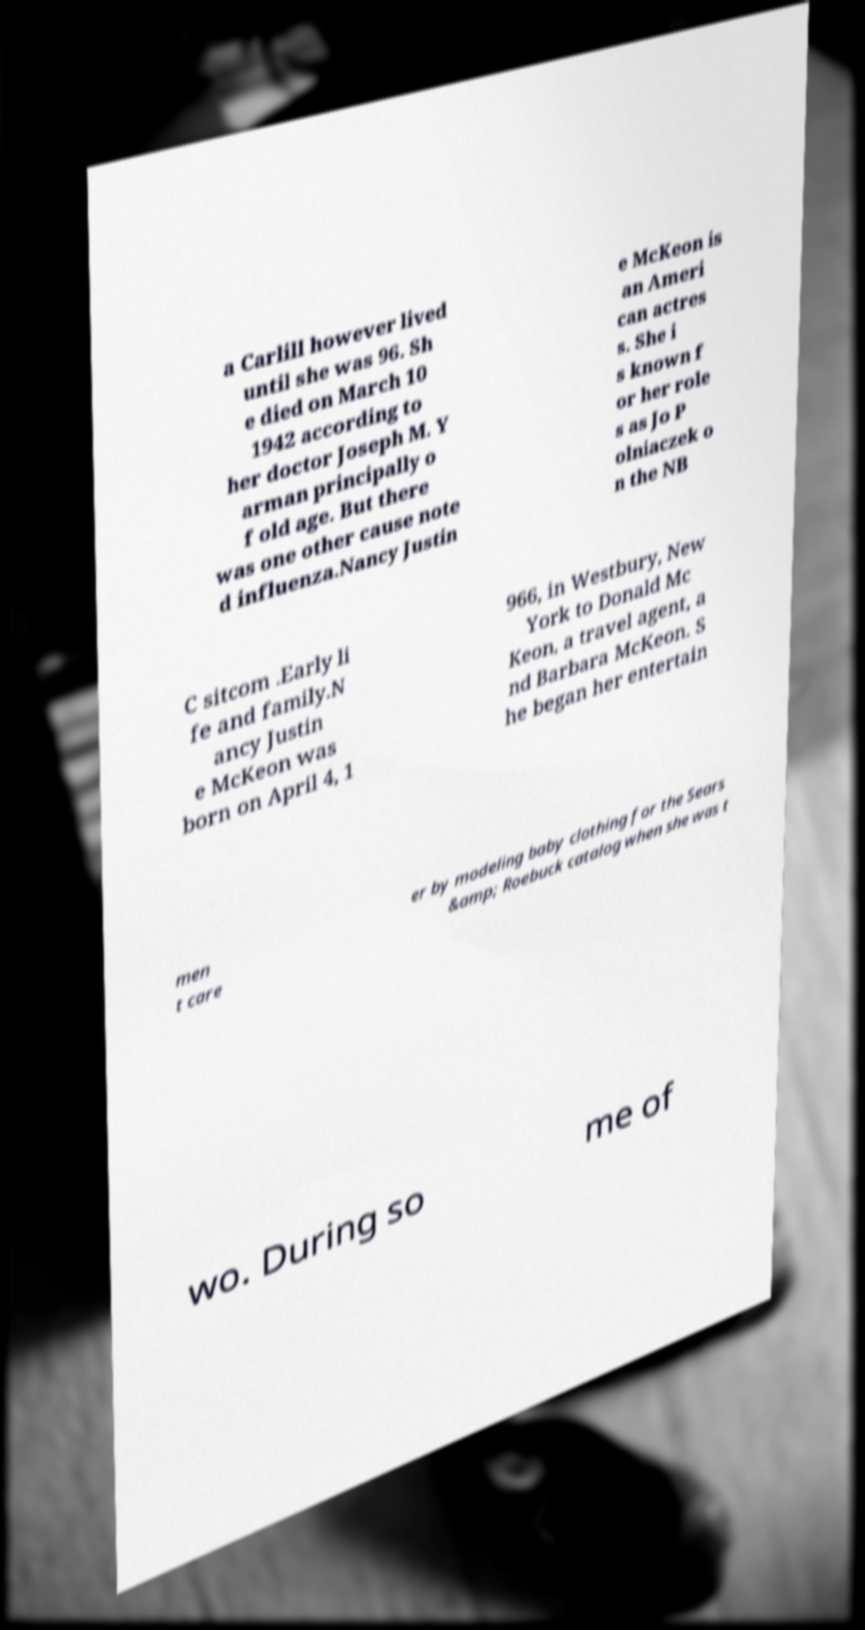Could you extract and type out the text from this image? a Carlill however lived until she was 96. Sh e died on March 10 1942 according to her doctor Joseph M. Y arman principally o f old age. But there was one other cause note d influenza.Nancy Justin e McKeon is an Ameri can actres s. She i s known f or her role s as Jo P olniaczek o n the NB C sitcom .Early li fe and family.N ancy Justin e McKeon was born on April 4, 1 966, in Westbury, New York to Donald Mc Keon, a travel agent, a nd Barbara McKeon. S he began her entertain men t care er by modeling baby clothing for the Sears &amp; Roebuck catalog when she was t wo. During so me of 